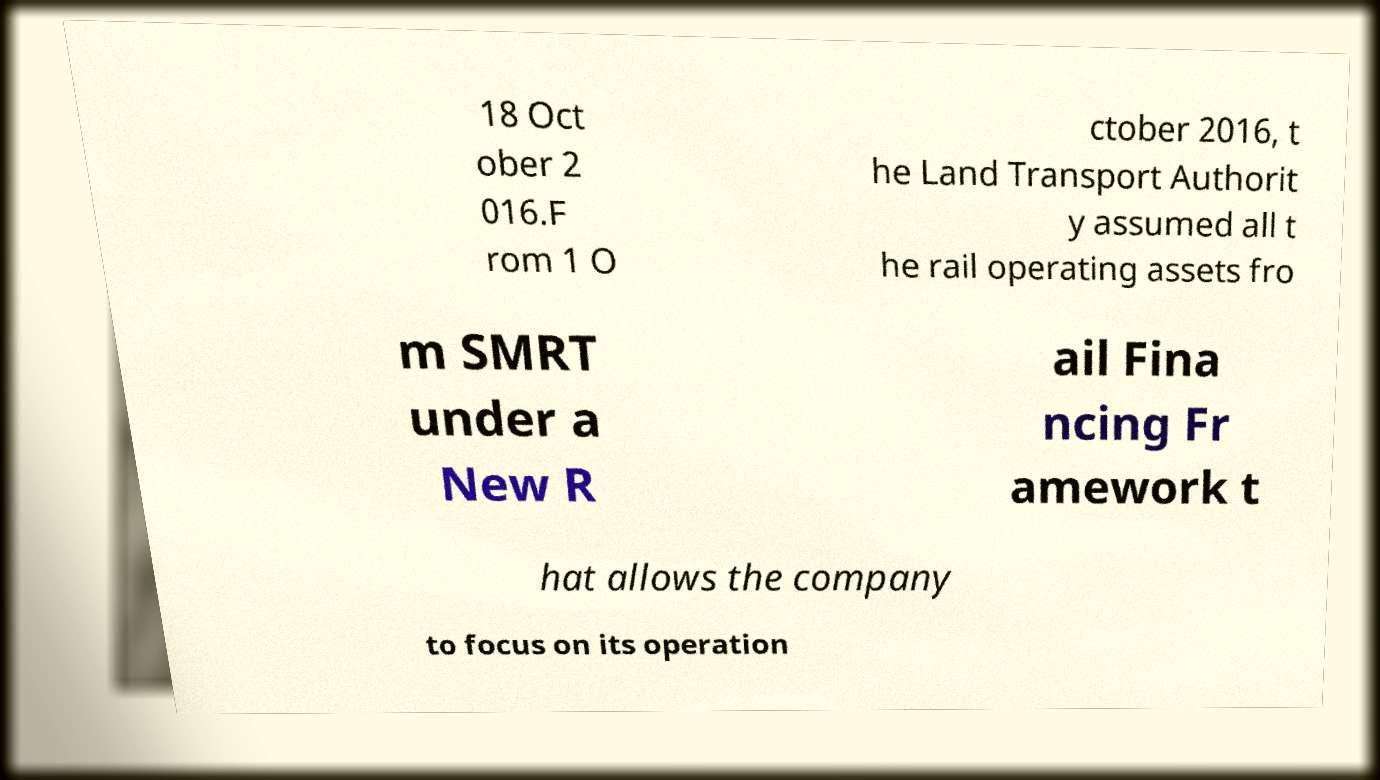What messages or text are displayed in this image? I need them in a readable, typed format. 18 Oct ober 2 016.F rom 1 O ctober 2016, t he Land Transport Authorit y assumed all t he rail operating assets fro m SMRT under a New R ail Fina ncing Fr amework t hat allows the company to focus on its operation 